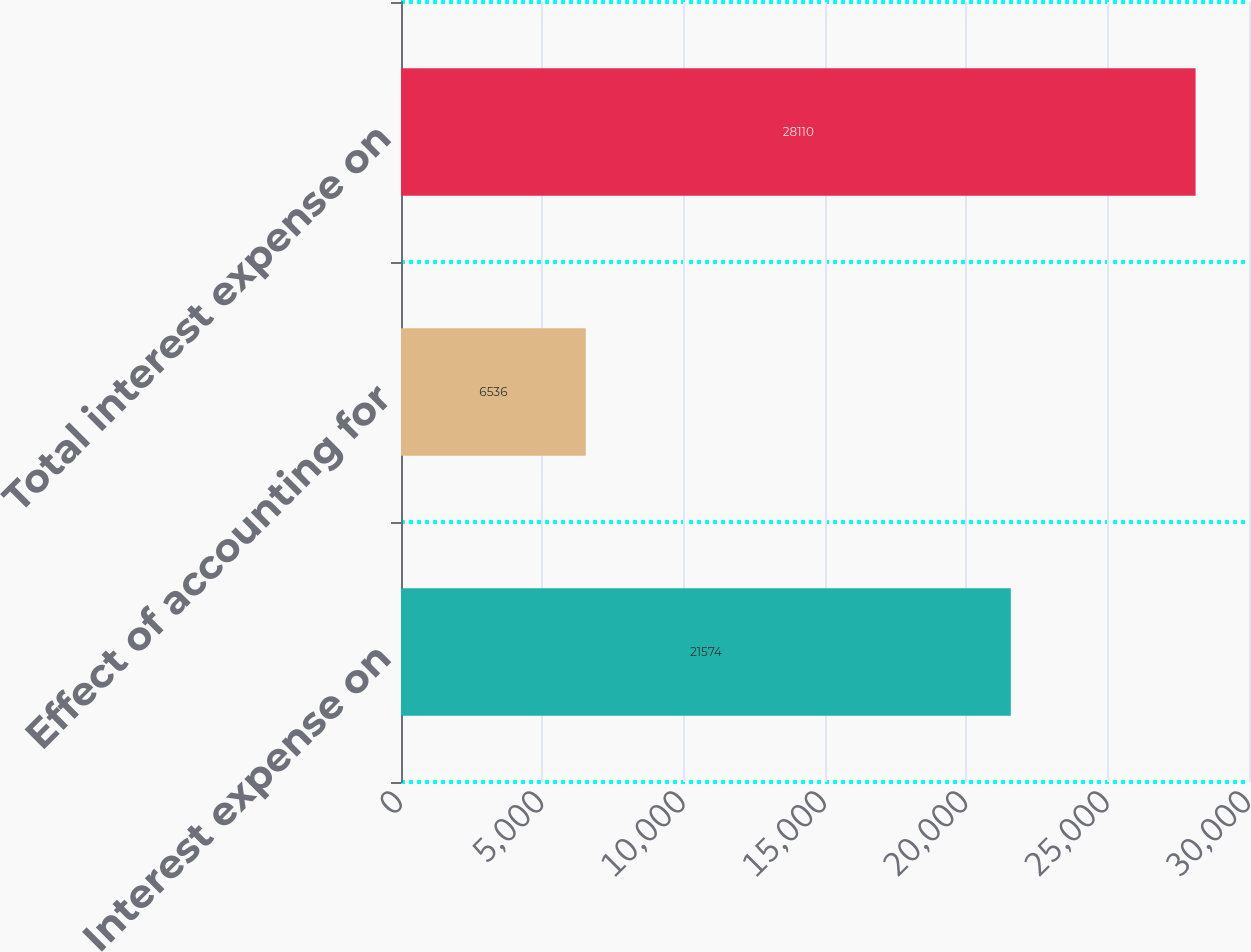Convert chart. <chart><loc_0><loc_0><loc_500><loc_500><bar_chart><fcel>Interest expense on<fcel>Effect of accounting for<fcel>Total interest expense on<nl><fcel>21574<fcel>6536<fcel>28110<nl></chart> 